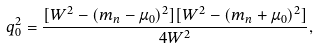<formula> <loc_0><loc_0><loc_500><loc_500>q _ { 0 } ^ { 2 } = \frac { [ W ^ { 2 } - ( m _ { n } - \mu _ { 0 } ) ^ { 2 } ] [ W ^ { 2 } - ( m _ { n } + \mu _ { 0 } ) ^ { 2 } ] } { 4 W ^ { 2 } } ,</formula> 